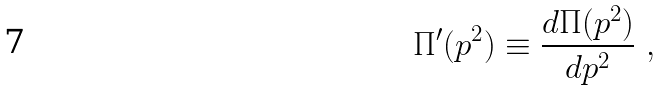Convert formula to latex. <formula><loc_0><loc_0><loc_500><loc_500>\Pi ^ { \prime } ( p ^ { 2 } ) \equiv \frac { d \Pi ( p ^ { 2 } ) } { d p ^ { 2 } } \ ,</formula> 